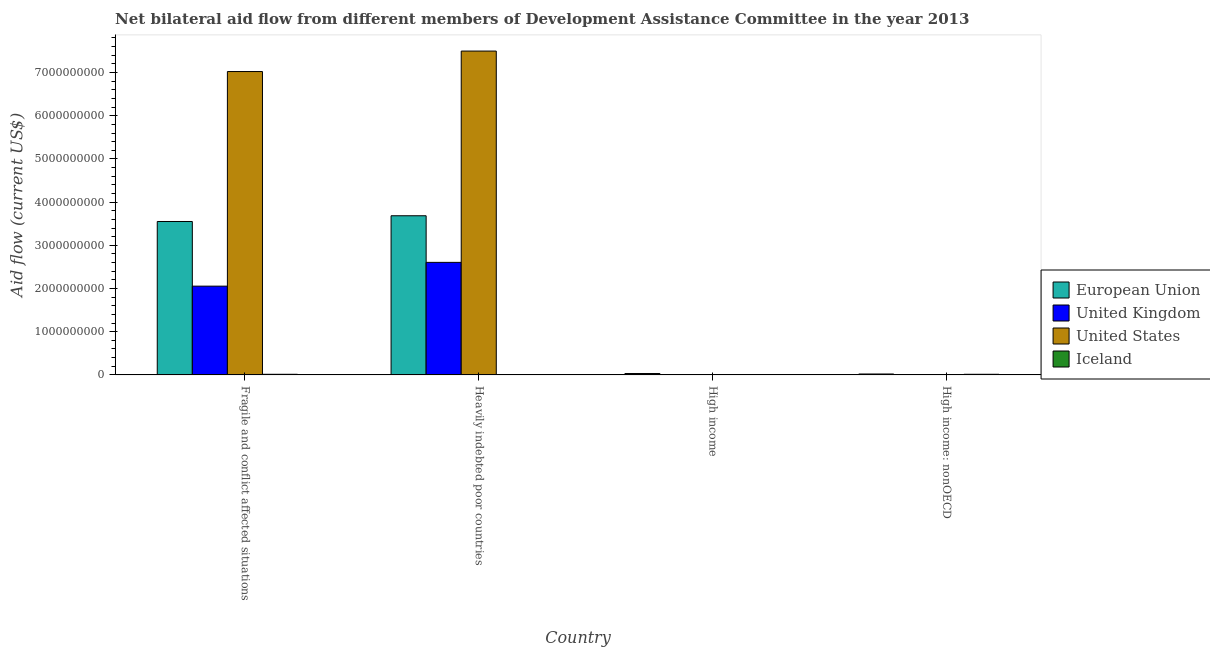How many different coloured bars are there?
Keep it short and to the point. 4. How many groups of bars are there?
Your response must be concise. 4. Are the number of bars per tick equal to the number of legend labels?
Ensure brevity in your answer.  Yes. Are the number of bars on each tick of the X-axis equal?
Your response must be concise. Yes. How many bars are there on the 2nd tick from the left?
Provide a succinct answer. 4. What is the label of the 4th group of bars from the left?
Make the answer very short. High income: nonOECD. What is the amount of aid given by uk in High income: nonOECD?
Your answer should be compact. 6.80e+05. Across all countries, what is the maximum amount of aid given by uk?
Your response must be concise. 2.61e+09. Across all countries, what is the minimum amount of aid given by iceland?
Your response must be concise. 1.50e+05. In which country was the amount of aid given by us maximum?
Your answer should be compact. Heavily indebted poor countries. In which country was the amount of aid given by uk minimum?
Make the answer very short. High income: nonOECD. What is the total amount of aid given by eu in the graph?
Give a very brief answer. 7.29e+09. What is the difference between the amount of aid given by uk in Fragile and conflict affected situations and that in High income?
Keep it short and to the point. 2.05e+09. What is the difference between the amount of aid given by us in High income and the amount of aid given by iceland in Fragile and conflict affected situations?
Your response must be concise. -1.22e+07. What is the average amount of aid given by iceland per country?
Keep it short and to the point. 7.24e+06. What is the difference between the amount of aid given by iceland and amount of aid given by uk in High income?
Your answer should be compact. -6.44e+06. What is the ratio of the amount of aid given by iceland in High income to that in High income: nonOECD?
Provide a succinct answer. 0.01. Is the amount of aid given by iceland in Heavily indebted poor countries less than that in High income: nonOECD?
Keep it short and to the point. Yes. What is the difference between the highest and the second highest amount of aid given by eu?
Offer a very short reply. 1.33e+08. What is the difference between the highest and the lowest amount of aid given by eu?
Give a very brief answer. 3.66e+09. In how many countries, is the amount of aid given by eu greater than the average amount of aid given by eu taken over all countries?
Your answer should be compact. 2. Is the sum of the amount of aid given by us in Fragile and conflict affected situations and Heavily indebted poor countries greater than the maximum amount of aid given by iceland across all countries?
Your response must be concise. Yes. Is it the case that in every country, the sum of the amount of aid given by uk and amount of aid given by iceland is greater than the sum of amount of aid given by us and amount of aid given by eu?
Ensure brevity in your answer.  No. What does the 1st bar from the left in High income: nonOECD represents?
Give a very brief answer. European Union. What does the 2nd bar from the right in Fragile and conflict affected situations represents?
Provide a succinct answer. United States. Is it the case that in every country, the sum of the amount of aid given by eu and amount of aid given by uk is greater than the amount of aid given by us?
Your response must be concise. No. Are the values on the major ticks of Y-axis written in scientific E-notation?
Offer a terse response. No. What is the title of the graph?
Your answer should be very brief. Net bilateral aid flow from different members of Development Assistance Committee in the year 2013. What is the Aid flow (current US$) in European Union in Fragile and conflict affected situations?
Your answer should be compact. 3.55e+09. What is the Aid flow (current US$) of United Kingdom in Fragile and conflict affected situations?
Your answer should be very brief. 2.05e+09. What is the Aid flow (current US$) in United States in Fragile and conflict affected situations?
Make the answer very short. 7.02e+09. What is the Aid flow (current US$) in Iceland in Fragile and conflict affected situations?
Provide a short and direct response. 1.44e+07. What is the Aid flow (current US$) of European Union in Heavily indebted poor countries?
Keep it short and to the point. 3.68e+09. What is the Aid flow (current US$) of United Kingdom in Heavily indebted poor countries?
Your answer should be very brief. 2.61e+09. What is the Aid flow (current US$) in United States in Heavily indebted poor countries?
Your answer should be very brief. 7.50e+09. What is the Aid flow (current US$) in Iceland in Heavily indebted poor countries?
Your response must be concise. 1.50e+05. What is the Aid flow (current US$) of European Union in High income?
Offer a very short reply. 3.22e+07. What is the Aid flow (current US$) of United Kingdom in High income?
Your answer should be very brief. 6.59e+06. What is the Aid flow (current US$) in United States in High income?
Provide a short and direct response. 2.17e+06. What is the Aid flow (current US$) of Iceland in High income?
Give a very brief answer. 1.50e+05. What is the Aid flow (current US$) of European Union in High income: nonOECD?
Ensure brevity in your answer.  2.13e+07. What is the Aid flow (current US$) of United Kingdom in High income: nonOECD?
Provide a succinct answer. 6.80e+05. What is the Aid flow (current US$) in United States in High income: nonOECD?
Your answer should be very brief. 6.40e+05. What is the Aid flow (current US$) of Iceland in High income: nonOECD?
Provide a succinct answer. 1.43e+07. Across all countries, what is the maximum Aid flow (current US$) in European Union?
Your answer should be compact. 3.68e+09. Across all countries, what is the maximum Aid flow (current US$) of United Kingdom?
Keep it short and to the point. 2.61e+09. Across all countries, what is the maximum Aid flow (current US$) of United States?
Ensure brevity in your answer.  7.50e+09. Across all countries, what is the maximum Aid flow (current US$) of Iceland?
Make the answer very short. 1.44e+07. Across all countries, what is the minimum Aid flow (current US$) of European Union?
Give a very brief answer. 2.13e+07. Across all countries, what is the minimum Aid flow (current US$) of United Kingdom?
Offer a very short reply. 6.80e+05. Across all countries, what is the minimum Aid flow (current US$) of United States?
Ensure brevity in your answer.  6.40e+05. What is the total Aid flow (current US$) of European Union in the graph?
Your answer should be very brief. 7.29e+09. What is the total Aid flow (current US$) in United Kingdom in the graph?
Provide a succinct answer. 4.67e+09. What is the total Aid flow (current US$) of United States in the graph?
Your answer should be very brief. 1.45e+1. What is the total Aid flow (current US$) of Iceland in the graph?
Your response must be concise. 2.90e+07. What is the difference between the Aid flow (current US$) in European Union in Fragile and conflict affected situations and that in Heavily indebted poor countries?
Offer a very short reply. -1.33e+08. What is the difference between the Aid flow (current US$) in United Kingdom in Fragile and conflict affected situations and that in Heavily indebted poor countries?
Offer a terse response. -5.51e+08. What is the difference between the Aid flow (current US$) in United States in Fragile and conflict affected situations and that in Heavily indebted poor countries?
Your response must be concise. -4.74e+08. What is the difference between the Aid flow (current US$) of Iceland in Fragile and conflict affected situations and that in Heavily indebted poor countries?
Your answer should be compact. 1.42e+07. What is the difference between the Aid flow (current US$) in European Union in Fragile and conflict affected situations and that in High income?
Make the answer very short. 3.52e+09. What is the difference between the Aid flow (current US$) of United Kingdom in Fragile and conflict affected situations and that in High income?
Offer a very short reply. 2.05e+09. What is the difference between the Aid flow (current US$) in United States in Fragile and conflict affected situations and that in High income?
Offer a terse response. 7.02e+09. What is the difference between the Aid flow (current US$) in Iceland in Fragile and conflict affected situations and that in High income?
Ensure brevity in your answer.  1.42e+07. What is the difference between the Aid flow (current US$) in European Union in Fragile and conflict affected situations and that in High income: nonOECD?
Your answer should be very brief. 3.53e+09. What is the difference between the Aid flow (current US$) of United Kingdom in Fragile and conflict affected situations and that in High income: nonOECD?
Keep it short and to the point. 2.05e+09. What is the difference between the Aid flow (current US$) of United States in Fragile and conflict affected situations and that in High income: nonOECD?
Offer a terse response. 7.02e+09. What is the difference between the Aid flow (current US$) of European Union in Heavily indebted poor countries and that in High income?
Provide a short and direct response. 3.65e+09. What is the difference between the Aid flow (current US$) of United Kingdom in Heavily indebted poor countries and that in High income?
Provide a short and direct response. 2.60e+09. What is the difference between the Aid flow (current US$) in United States in Heavily indebted poor countries and that in High income?
Your response must be concise. 7.49e+09. What is the difference between the Aid flow (current US$) of European Union in Heavily indebted poor countries and that in High income: nonOECD?
Offer a terse response. 3.66e+09. What is the difference between the Aid flow (current US$) in United Kingdom in Heavily indebted poor countries and that in High income: nonOECD?
Offer a very short reply. 2.60e+09. What is the difference between the Aid flow (current US$) of United States in Heavily indebted poor countries and that in High income: nonOECD?
Offer a terse response. 7.50e+09. What is the difference between the Aid flow (current US$) of Iceland in Heavily indebted poor countries and that in High income: nonOECD?
Give a very brief answer. -1.41e+07. What is the difference between the Aid flow (current US$) in European Union in High income and that in High income: nonOECD?
Your response must be concise. 1.10e+07. What is the difference between the Aid flow (current US$) in United Kingdom in High income and that in High income: nonOECD?
Offer a terse response. 5.91e+06. What is the difference between the Aid flow (current US$) of United States in High income and that in High income: nonOECD?
Your answer should be compact. 1.53e+06. What is the difference between the Aid flow (current US$) in Iceland in High income and that in High income: nonOECD?
Offer a terse response. -1.41e+07. What is the difference between the Aid flow (current US$) of European Union in Fragile and conflict affected situations and the Aid flow (current US$) of United Kingdom in Heavily indebted poor countries?
Your answer should be very brief. 9.46e+08. What is the difference between the Aid flow (current US$) in European Union in Fragile and conflict affected situations and the Aid flow (current US$) in United States in Heavily indebted poor countries?
Give a very brief answer. -3.95e+09. What is the difference between the Aid flow (current US$) in European Union in Fragile and conflict affected situations and the Aid flow (current US$) in Iceland in Heavily indebted poor countries?
Offer a very short reply. 3.55e+09. What is the difference between the Aid flow (current US$) in United Kingdom in Fragile and conflict affected situations and the Aid flow (current US$) in United States in Heavily indebted poor countries?
Your response must be concise. -5.44e+09. What is the difference between the Aid flow (current US$) in United Kingdom in Fragile and conflict affected situations and the Aid flow (current US$) in Iceland in Heavily indebted poor countries?
Give a very brief answer. 2.05e+09. What is the difference between the Aid flow (current US$) in United States in Fragile and conflict affected situations and the Aid flow (current US$) in Iceland in Heavily indebted poor countries?
Your response must be concise. 7.02e+09. What is the difference between the Aid flow (current US$) in European Union in Fragile and conflict affected situations and the Aid flow (current US$) in United Kingdom in High income?
Ensure brevity in your answer.  3.54e+09. What is the difference between the Aid flow (current US$) of European Union in Fragile and conflict affected situations and the Aid flow (current US$) of United States in High income?
Provide a succinct answer. 3.55e+09. What is the difference between the Aid flow (current US$) in European Union in Fragile and conflict affected situations and the Aid flow (current US$) in Iceland in High income?
Your response must be concise. 3.55e+09. What is the difference between the Aid flow (current US$) of United Kingdom in Fragile and conflict affected situations and the Aid flow (current US$) of United States in High income?
Ensure brevity in your answer.  2.05e+09. What is the difference between the Aid flow (current US$) in United Kingdom in Fragile and conflict affected situations and the Aid flow (current US$) in Iceland in High income?
Your answer should be compact. 2.05e+09. What is the difference between the Aid flow (current US$) in United States in Fragile and conflict affected situations and the Aid flow (current US$) in Iceland in High income?
Your response must be concise. 7.02e+09. What is the difference between the Aid flow (current US$) of European Union in Fragile and conflict affected situations and the Aid flow (current US$) of United Kingdom in High income: nonOECD?
Your response must be concise. 3.55e+09. What is the difference between the Aid flow (current US$) in European Union in Fragile and conflict affected situations and the Aid flow (current US$) in United States in High income: nonOECD?
Provide a short and direct response. 3.55e+09. What is the difference between the Aid flow (current US$) in European Union in Fragile and conflict affected situations and the Aid flow (current US$) in Iceland in High income: nonOECD?
Give a very brief answer. 3.54e+09. What is the difference between the Aid flow (current US$) in United Kingdom in Fragile and conflict affected situations and the Aid flow (current US$) in United States in High income: nonOECD?
Your response must be concise. 2.05e+09. What is the difference between the Aid flow (current US$) in United Kingdom in Fragile and conflict affected situations and the Aid flow (current US$) in Iceland in High income: nonOECD?
Offer a very short reply. 2.04e+09. What is the difference between the Aid flow (current US$) of United States in Fragile and conflict affected situations and the Aid flow (current US$) of Iceland in High income: nonOECD?
Your answer should be very brief. 7.01e+09. What is the difference between the Aid flow (current US$) in European Union in Heavily indebted poor countries and the Aid flow (current US$) in United Kingdom in High income?
Provide a short and direct response. 3.68e+09. What is the difference between the Aid flow (current US$) in European Union in Heavily indebted poor countries and the Aid flow (current US$) in United States in High income?
Your answer should be very brief. 3.68e+09. What is the difference between the Aid flow (current US$) of European Union in Heavily indebted poor countries and the Aid flow (current US$) of Iceland in High income?
Offer a terse response. 3.68e+09. What is the difference between the Aid flow (current US$) of United Kingdom in Heavily indebted poor countries and the Aid flow (current US$) of United States in High income?
Ensure brevity in your answer.  2.60e+09. What is the difference between the Aid flow (current US$) of United Kingdom in Heavily indebted poor countries and the Aid flow (current US$) of Iceland in High income?
Provide a short and direct response. 2.61e+09. What is the difference between the Aid flow (current US$) of United States in Heavily indebted poor countries and the Aid flow (current US$) of Iceland in High income?
Provide a short and direct response. 7.50e+09. What is the difference between the Aid flow (current US$) in European Union in Heavily indebted poor countries and the Aid flow (current US$) in United Kingdom in High income: nonOECD?
Keep it short and to the point. 3.68e+09. What is the difference between the Aid flow (current US$) in European Union in Heavily indebted poor countries and the Aid flow (current US$) in United States in High income: nonOECD?
Your answer should be compact. 3.68e+09. What is the difference between the Aid flow (current US$) in European Union in Heavily indebted poor countries and the Aid flow (current US$) in Iceland in High income: nonOECD?
Keep it short and to the point. 3.67e+09. What is the difference between the Aid flow (current US$) of United Kingdom in Heavily indebted poor countries and the Aid flow (current US$) of United States in High income: nonOECD?
Ensure brevity in your answer.  2.60e+09. What is the difference between the Aid flow (current US$) of United Kingdom in Heavily indebted poor countries and the Aid flow (current US$) of Iceland in High income: nonOECD?
Keep it short and to the point. 2.59e+09. What is the difference between the Aid flow (current US$) in United States in Heavily indebted poor countries and the Aid flow (current US$) in Iceland in High income: nonOECD?
Provide a succinct answer. 7.48e+09. What is the difference between the Aid flow (current US$) of European Union in High income and the Aid flow (current US$) of United Kingdom in High income: nonOECD?
Give a very brief answer. 3.16e+07. What is the difference between the Aid flow (current US$) in European Union in High income and the Aid flow (current US$) in United States in High income: nonOECD?
Provide a short and direct response. 3.16e+07. What is the difference between the Aid flow (current US$) of European Union in High income and the Aid flow (current US$) of Iceland in High income: nonOECD?
Keep it short and to the point. 1.80e+07. What is the difference between the Aid flow (current US$) of United Kingdom in High income and the Aid flow (current US$) of United States in High income: nonOECD?
Offer a very short reply. 5.95e+06. What is the difference between the Aid flow (current US$) of United Kingdom in High income and the Aid flow (current US$) of Iceland in High income: nonOECD?
Your answer should be compact. -7.70e+06. What is the difference between the Aid flow (current US$) of United States in High income and the Aid flow (current US$) of Iceland in High income: nonOECD?
Offer a terse response. -1.21e+07. What is the average Aid flow (current US$) in European Union per country?
Offer a very short reply. 1.82e+09. What is the average Aid flow (current US$) of United Kingdom per country?
Your response must be concise. 1.17e+09. What is the average Aid flow (current US$) in United States per country?
Offer a very short reply. 3.63e+09. What is the average Aid flow (current US$) of Iceland per country?
Make the answer very short. 7.24e+06. What is the difference between the Aid flow (current US$) in European Union and Aid flow (current US$) in United Kingdom in Fragile and conflict affected situations?
Your response must be concise. 1.50e+09. What is the difference between the Aid flow (current US$) in European Union and Aid flow (current US$) in United States in Fragile and conflict affected situations?
Give a very brief answer. -3.47e+09. What is the difference between the Aid flow (current US$) of European Union and Aid flow (current US$) of Iceland in Fragile and conflict affected situations?
Offer a very short reply. 3.54e+09. What is the difference between the Aid flow (current US$) in United Kingdom and Aid flow (current US$) in United States in Fragile and conflict affected situations?
Give a very brief answer. -4.97e+09. What is the difference between the Aid flow (current US$) of United Kingdom and Aid flow (current US$) of Iceland in Fragile and conflict affected situations?
Your answer should be very brief. 2.04e+09. What is the difference between the Aid flow (current US$) in United States and Aid flow (current US$) in Iceland in Fragile and conflict affected situations?
Provide a succinct answer. 7.01e+09. What is the difference between the Aid flow (current US$) in European Union and Aid flow (current US$) in United Kingdom in Heavily indebted poor countries?
Make the answer very short. 1.08e+09. What is the difference between the Aid flow (current US$) of European Union and Aid flow (current US$) of United States in Heavily indebted poor countries?
Provide a succinct answer. -3.81e+09. What is the difference between the Aid flow (current US$) of European Union and Aid flow (current US$) of Iceland in Heavily indebted poor countries?
Your answer should be very brief. 3.68e+09. What is the difference between the Aid flow (current US$) in United Kingdom and Aid flow (current US$) in United States in Heavily indebted poor countries?
Your response must be concise. -4.89e+09. What is the difference between the Aid flow (current US$) in United Kingdom and Aid flow (current US$) in Iceland in Heavily indebted poor countries?
Provide a short and direct response. 2.61e+09. What is the difference between the Aid flow (current US$) in United States and Aid flow (current US$) in Iceland in Heavily indebted poor countries?
Give a very brief answer. 7.50e+09. What is the difference between the Aid flow (current US$) in European Union and Aid flow (current US$) in United Kingdom in High income?
Ensure brevity in your answer.  2.57e+07. What is the difference between the Aid flow (current US$) in European Union and Aid flow (current US$) in United States in High income?
Your response must be concise. 3.01e+07. What is the difference between the Aid flow (current US$) of European Union and Aid flow (current US$) of Iceland in High income?
Keep it short and to the point. 3.21e+07. What is the difference between the Aid flow (current US$) of United Kingdom and Aid flow (current US$) of United States in High income?
Your answer should be very brief. 4.42e+06. What is the difference between the Aid flow (current US$) in United Kingdom and Aid flow (current US$) in Iceland in High income?
Offer a terse response. 6.44e+06. What is the difference between the Aid flow (current US$) of United States and Aid flow (current US$) of Iceland in High income?
Offer a very short reply. 2.02e+06. What is the difference between the Aid flow (current US$) of European Union and Aid flow (current US$) of United Kingdom in High income: nonOECD?
Make the answer very short. 2.06e+07. What is the difference between the Aid flow (current US$) in European Union and Aid flow (current US$) in United States in High income: nonOECD?
Make the answer very short. 2.06e+07. What is the difference between the Aid flow (current US$) in European Union and Aid flow (current US$) in Iceland in High income: nonOECD?
Offer a very short reply. 6.99e+06. What is the difference between the Aid flow (current US$) of United Kingdom and Aid flow (current US$) of Iceland in High income: nonOECD?
Your answer should be very brief. -1.36e+07. What is the difference between the Aid flow (current US$) in United States and Aid flow (current US$) in Iceland in High income: nonOECD?
Offer a terse response. -1.36e+07. What is the ratio of the Aid flow (current US$) in United Kingdom in Fragile and conflict affected situations to that in Heavily indebted poor countries?
Give a very brief answer. 0.79. What is the ratio of the Aid flow (current US$) in United States in Fragile and conflict affected situations to that in Heavily indebted poor countries?
Give a very brief answer. 0.94. What is the ratio of the Aid flow (current US$) of Iceland in Fragile and conflict affected situations to that in Heavily indebted poor countries?
Make the answer very short. 95.8. What is the ratio of the Aid flow (current US$) in European Union in Fragile and conflict affected situations to that in High income?
Keep it short and to the point. 110.12. What is the ratio of the Aid flow (current US$) of United Kingdom in Fragile and conflict affected situations to that in High income?
Make the answer very short. 311.8. What is the ratio of the Aid flow (current US$) of United States in Fragile and conflict affected situations to that in High income?
Your answer should be compact. 3236.37. What is the ratio of the Aid flow (current US$) of Iceland in Fragile and conflict affected situations to that in High income?
Your answer should be compact. 95.8. What is the ratio of the Aid flow (current US$) of European Union in Fragile and conflict affected situations to that in High income: nonOECD?
Ensure brevity in your answer.  166.9. What is the ratio of the Aid flow (current US$) of United Kingdom in Fragile and conflict affected situations to that in High income: nonOECD?
Your response must be concise. 3021.68. What is the ratio of the Aid flow (current US$) of United States in Fragile and conflict affected situations to that in High income: nonOECD?
Keep it short and to the point. 1.10e+04. What is the ratio of the Aid flow (current US$) of Iceland in Fragile and conflict affected situations to that in High income: nonOECD?
Provide a succinct answer. 1.01. What is the ratio of the Aid flow (current US$) in European Union in Heavily indebted poor countries to that in High income?
Ensure brevity in your answer.  114.24. What is the ratio of the Aid flow (current US$) in United Kingdom in Heavily indebted poor countries to that in High income?
Provide a succinct answer. 395.33. What is the ratio of the Aid flow (current US$) in United States in Heavily indebted poor countries to that in High income?
Offer a very short reply. 3454.74. What is the ratio of the Aid flow (current US$) in Iceland in Heavily indebted poor countries to that in High income?
Provide a short and direct response. 1. What is the ratio of the Aid flow (current US$) of European Union in Heavily indebted poor countries to that in High income: nonOECD?
Offer a very short reply. 173.13. What is the ratio of the Aid flow (current US$) in United Kingdom in Heavily indebted poor countries to that in High income: nonOECD?
Provide a short and direct response. 3831.25. What is the ratio of the Aid flow (current US$) of United States in Heavily indebted poor countries to that in High income: nonOECD?
Your answer should be compact. 1.17e+04. What is the ratio of the Aid flow (current US$) of Iceland in Heavily indebted poor countries to that in High income: nonOECD?
Provide a short and direct response. 0.01. What is the ratio of the Aid flow (current US$) in European Union in High income to that in High income: nonOECD?
Provide a short and direct response. 1.52. What is the ratio of the Aid flow (current US$) in United Kingdom in High income to that in High income: nonOECD?
Keep it short and to the point. 9.69. What is the ratio of the Aid flow (current US$) of United States in High income to that in High income: nonOECD?
Make the answer very short. 3.39. What is the ratio of the Aid flow (current US$) of Iceland in High income to that in High income: nonOECD?
Your answer should be very brief. 0.01. What is the difference between the highest and the second highest Aid flow (current US$) in European Union?
Give a very brief answer. 1.33e+08. What is the difference between the highest and the second highest Aid flow (current US$) in United Kingdom?
Provide a succinct answer. 5.51e+08. What is the difference between the highest and the second highest Aid flow (current US$) of United States?
Offer a terse response. 4.74e+08. What is the difference between the highest and the second highest Aid flow (current US$) of Iceland?
Provide a succinct answer. 8.00e+04. What is the difference between the highest and the lowest Aid flow (current US$) of European Union?
Ensure brevity in your answer.  3.66e+09. What is the difference between the highest and the lowest Aid flow (current US$) in United Kingdom?
Give a very brief answer. 2.60e+09. What is the difference between the highest and the lowest Aid flow (current US$) in United States?
Your response must be concise. 7.50e+09. What is the difference between the highest and the lowest Aid flow (current US$) in Iceland?
Offer a very short reply. 1.42e+07. 